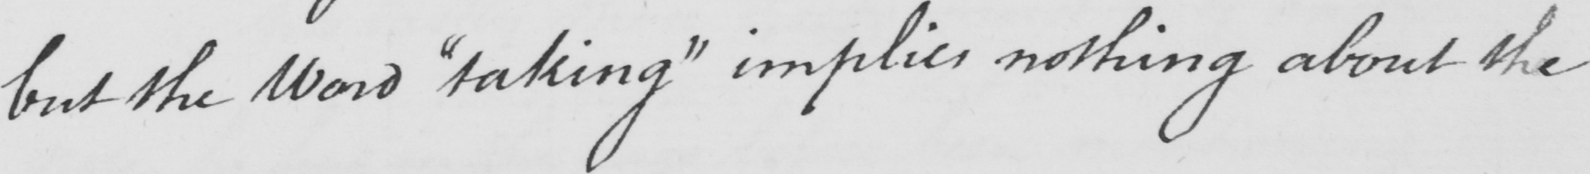Can you read and transcribe this handwriting? but the word  " taking "  implies nothing about the 